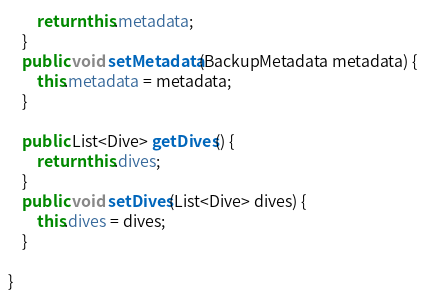Convert code to text. <code><loc_0><loc_0><loc_500><loc_500><_Java_>        return this.metadata;
    }
    public void setMetadata(BackupMetadata metadata) {
        this.metadata = metadata;
    }

    public List<Dive> getDives() {
        return this.dives;
    }
    public void setDives(List<Dive> dives) {
        this.dives = dives;
    }

}
</code> 